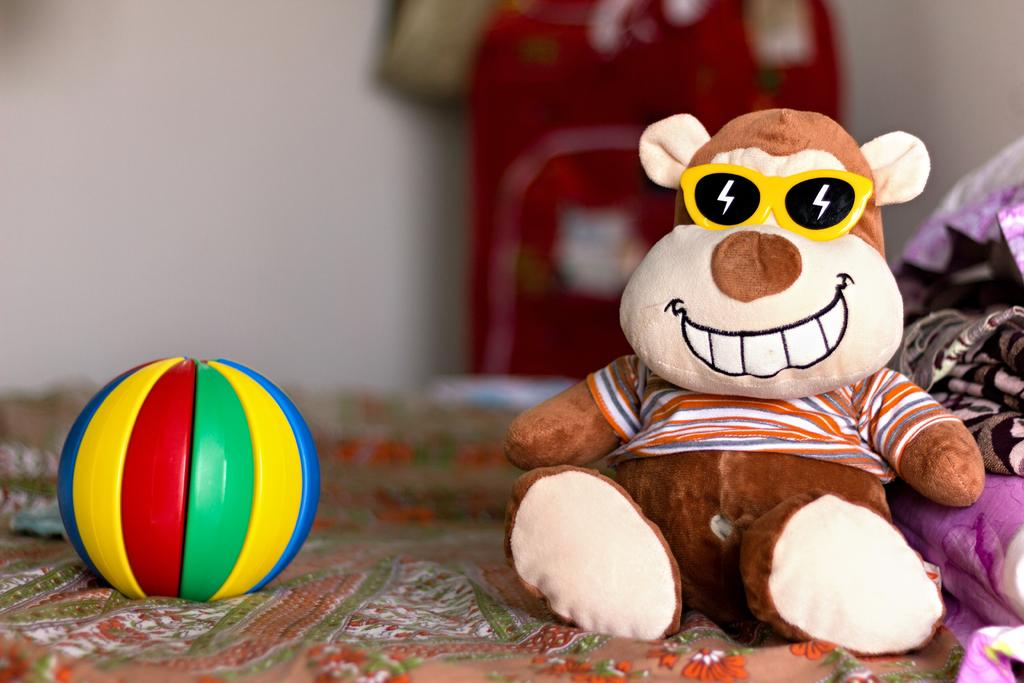What type of toy is in the image? There is a teddy bear in the image. What other object can be seen in the image? There is a ball in the image. What else is present in the image besides the teddy bear and ball? Clothes are present in the image. What can be seen in the background of the image? There is a wall and other objects in the background of the image. How would you describe the background of the image? The background is blurry. How many pets are visible in the image? There are no pets visible in the image. What type of toad can be seen interacting with the teddy bear in the image? There is no toad present in the image, and the teddy bear is not interacting with any other object or creature. 